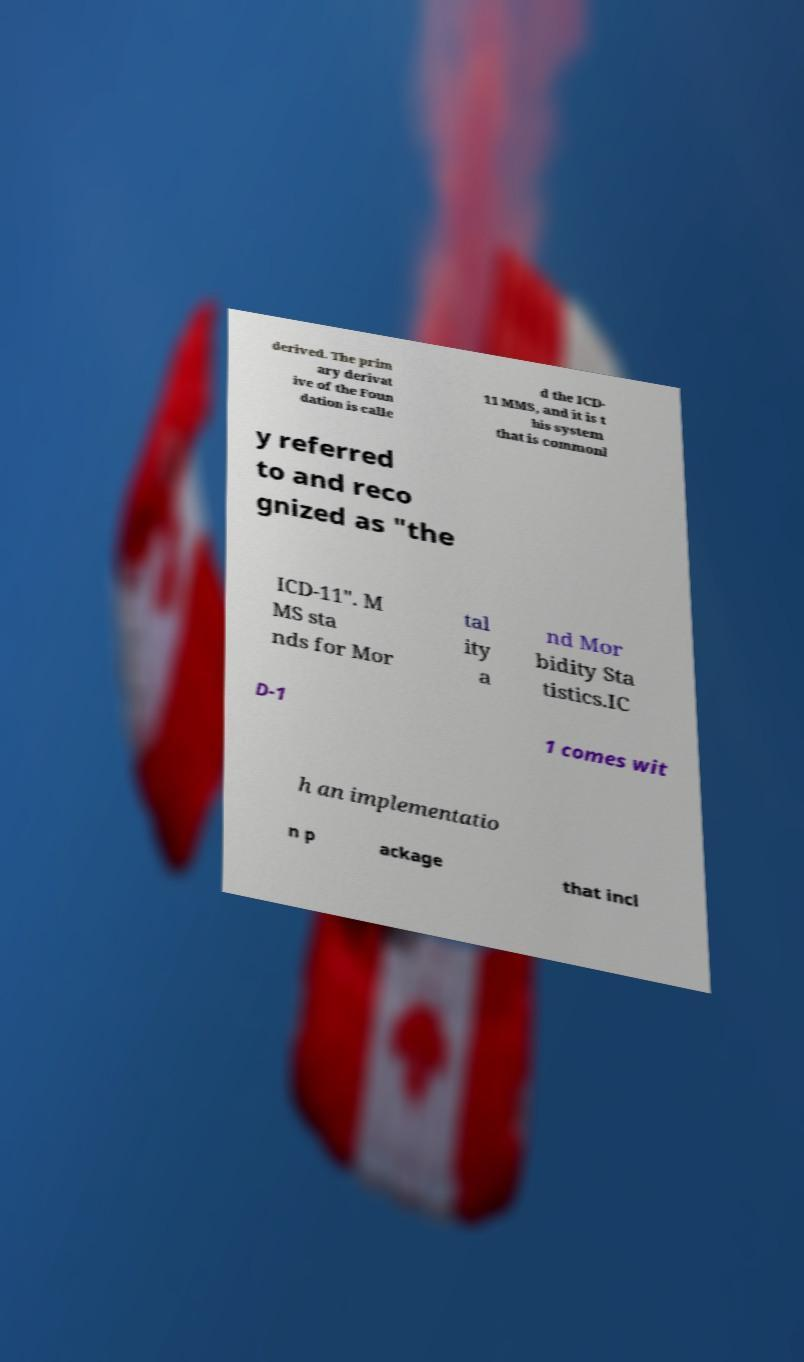What messages or text are displayed in this image? I need them in a readable, typed format. derived. The prim ary derivat ive of the Foun dation is calle d the ICD- 11 MMS, and it is t his system that is commonl y referred to and reco gnized as "the ICD-11". M MS sta nds for Mor tal ity a nd Mor bidity Sta tistics.IC D-1 1 comes wit h an implementatio n p ackage that incl 